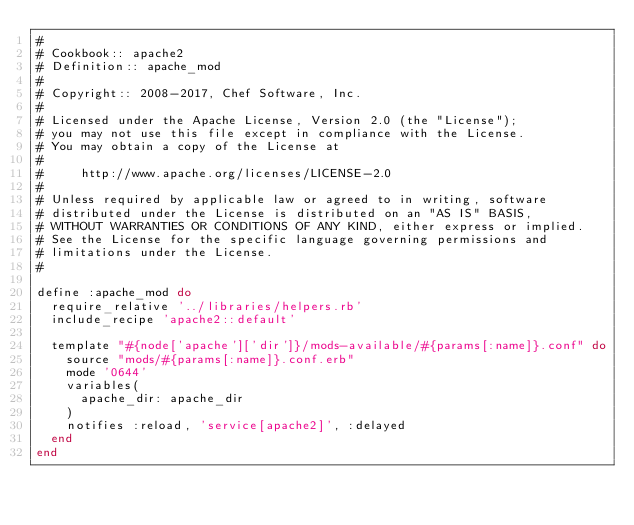Convert code to text. <code><loc_0><loc_0><loc_500><loc_500><_Ruby_>#
# Cookbook:: apache2
# Definition:: apache_mod
#
# Copyright:: 2008-2017, Chef Software, Inc.
#
# Licensed under the Apache License, Version 2.0 (the "License");
# you may not use this file except in compliance with the License.
# You may obtain a copy of the License at
#
#     http://www.apache.org/licenses/LICENSE-2.0
#
# Unless required by applicable law or agreed to in writing, software
# distributed under the License is distributed on an "AS IS" BASIS,
# WITHOUT WARRANTIES OR CONDITIONS OF ANY KIND, either express or implied.
# See the License for the specific language governing permissions and
# limitations under the License.
#

define :apache_mod do
  require_relative '../libraries/helpers.rb'
  include_recipe 'apache2::default'

  template "#{node['apache']['dir']}/mods-available/#{params[:name]}.conf" do
    source "mods/#{params[:name]}.conf.erb"
    mode '0644'
    variables(
      apache_dir: apache_dir
    )
    notifies :reload, 'service[apache2]', :delayed
  end
end
</code> 